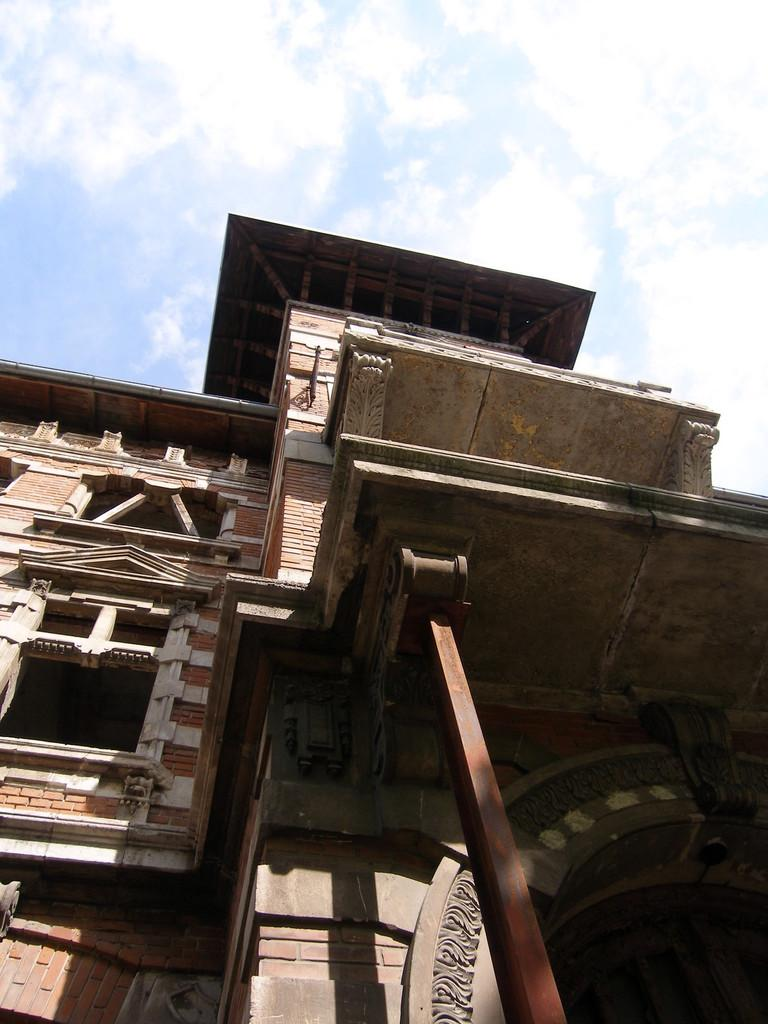What is there is a structure visible in the image, what is it? There is a building in the image. What can be seen in the distance behind the building? The sky is visible in the background of the image. Can you describe the fight that is taking place in the image? There is no fight present in the image; it only features a building and the sky in the background. 